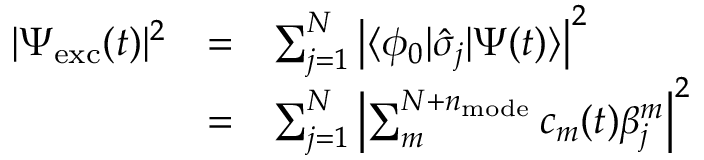<formula> <loc_0><loc_0><loc_500><loc_500>\begin{array} { c c l } { | \Psi _ { e x c } ( t ) | ^ { 2 } } & { = } & { \sum _ { j = 1 } ^ { N } \left | \langle \phi _ { 0 } | \hat { \sigma } _ { j } | \Psi ( t ) \rangle \right | ^ { 2 } } \\ & { = } & { \sum _ { j = 1 } ^ { N } \left | \sum _ { m } ^ { N + n _ { m o d e } } c _ { m } ( t ) \beta _ { j } ^ { m } \right | ^ { 2 } } \end{array}</formula> 